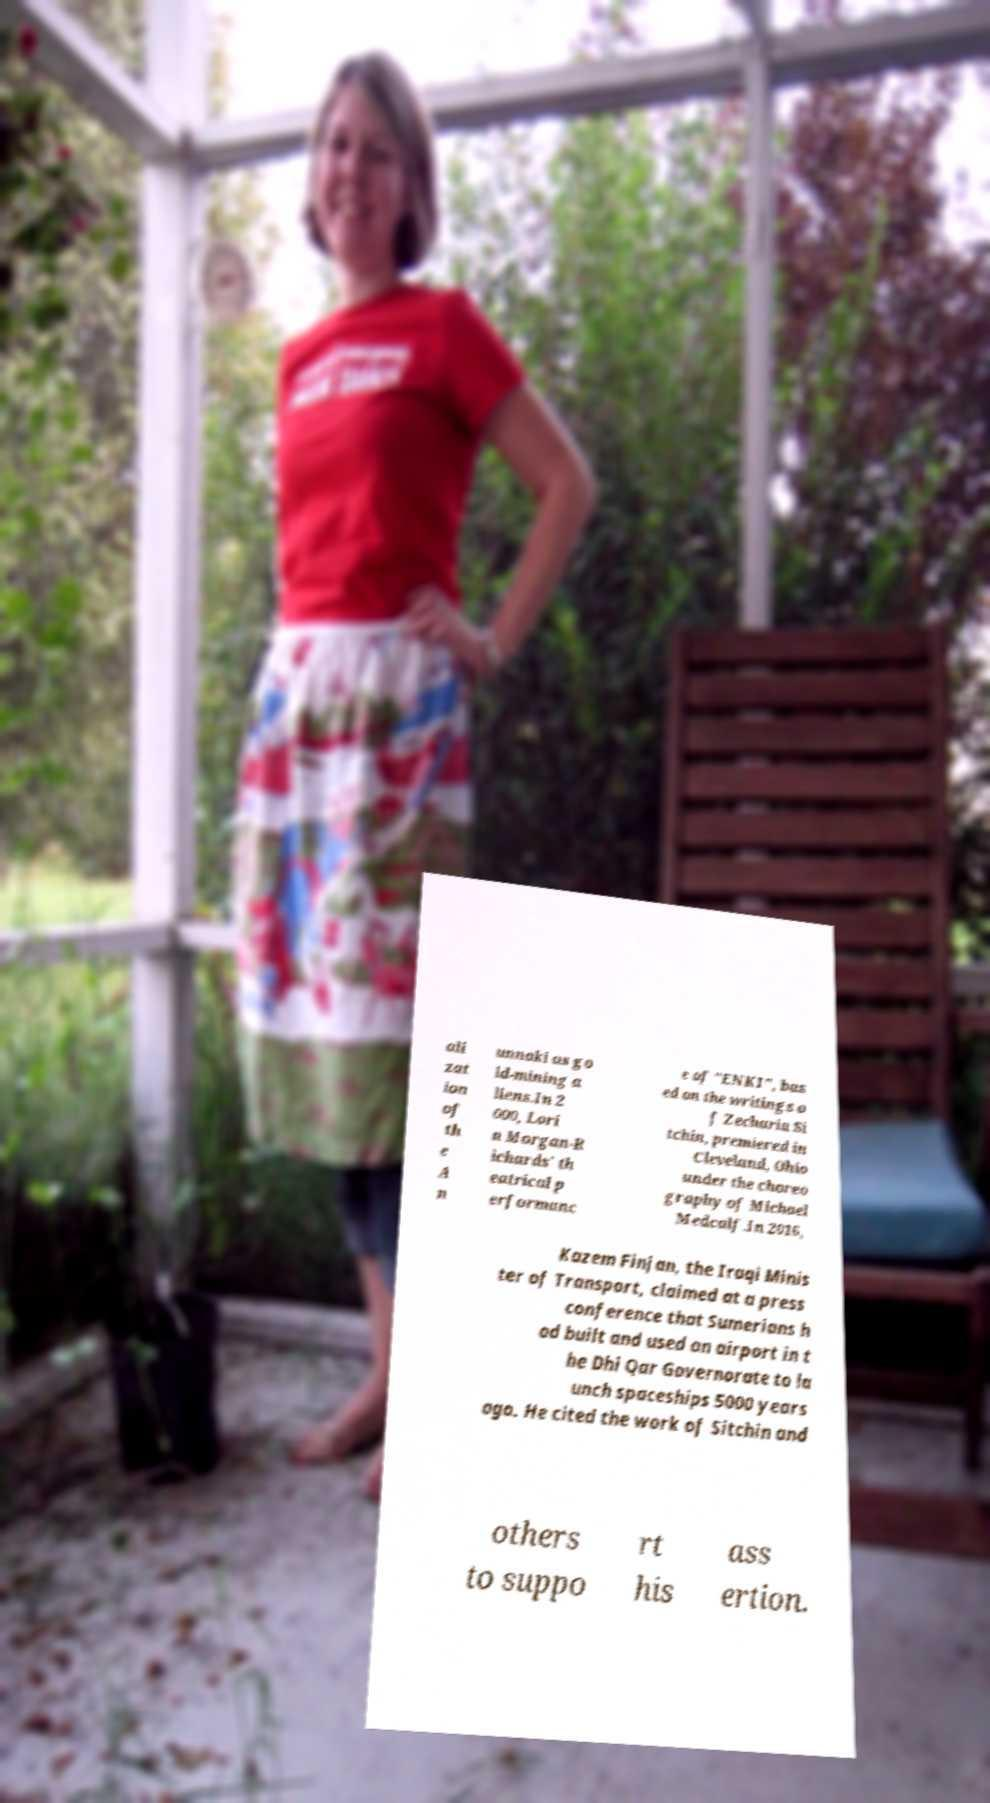Can you read and provide the text displayed in the image?This photo seems to have some interesting text. Can you extract and type it out for me? ali zat ion of th e A n unnaki as go ld-mining a liens.In 2 000, Lori n Morgan-R ichards' th eatrical p erformanc e of "ENKI", bas ed on the writings o f Zecharia Si tchin, premiered in Cleveland, Ohio under the choreo graphy of Michael Medcalf.In 2016, Kazem Finjan, the Iraqi Minis ter of Transport, claimed at a press conference that Sumerians h ad built and used an airport in t he Dhi Qar Governorate to la unch spaceships 5000 years ago. He cited the work of Sitchin and others to suppo rt his ass ertion. 